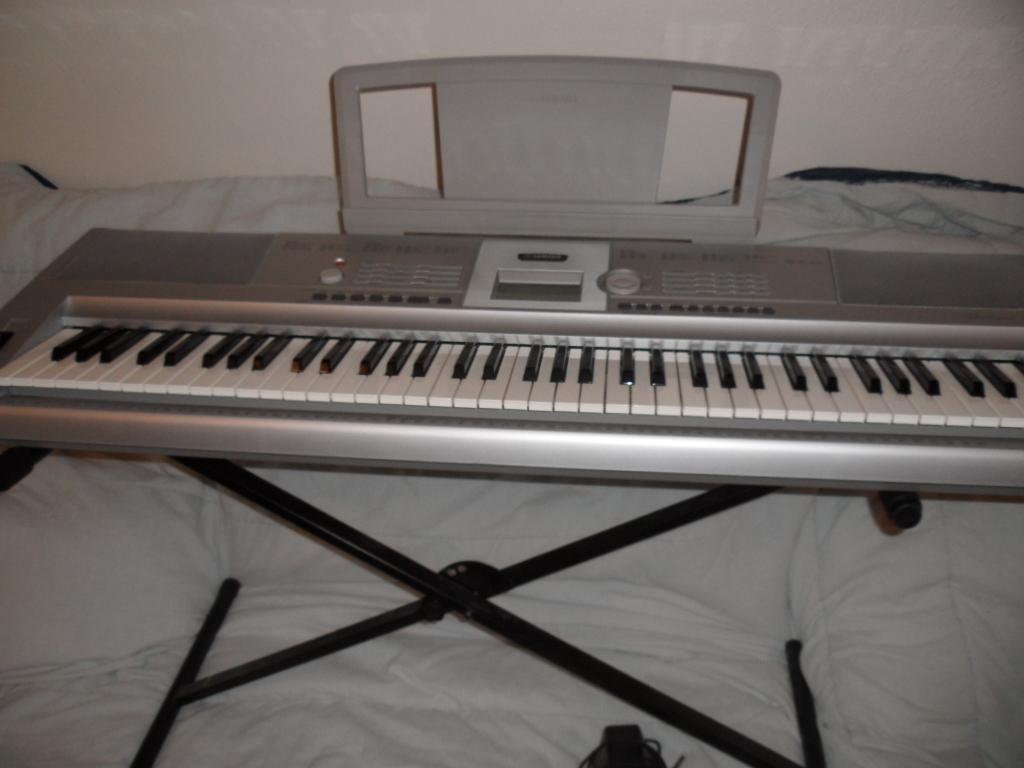Please provide a concise description of this image. We can see keyboard with stand on the bed and this keyboard contain black and white keys. Behind this bed we can see wall. 